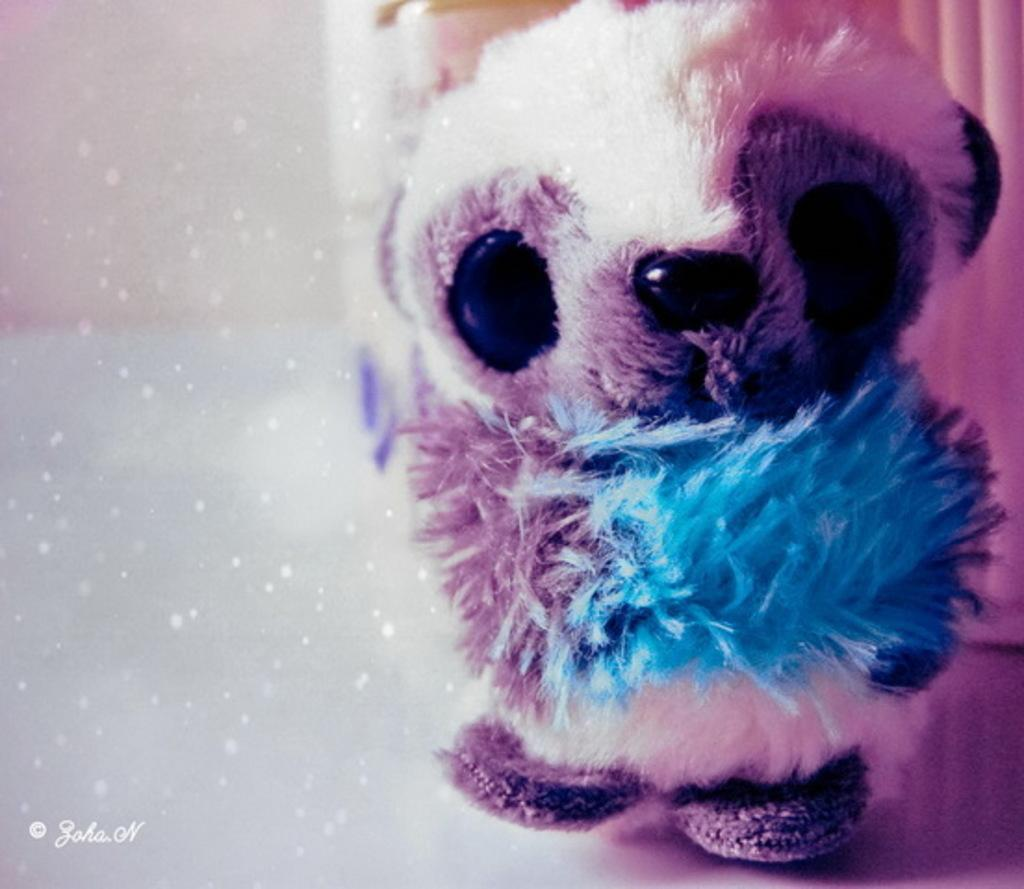What is the main subject in the image? There is a doll in the image. Can you describe the background of the image? The background of the image is blurred. Is there any additional mark or feature in the image? Yes, there is a watermark in the left corner of the image. What type of amusement can be seen in the image? There is no amusement present in the image; it features a doll and a blurred background. Is there a collar visible on the doll in the image? There is no collar visible on the doll in the image. 